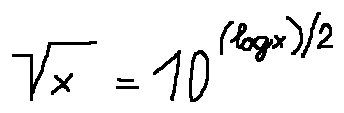Convert formula to latex. <formula><loc_0><loc_0><loc_500><loc_500>\sqrt { x } = 1 0 ^ { ( \log x ) / 2 }</formula> 